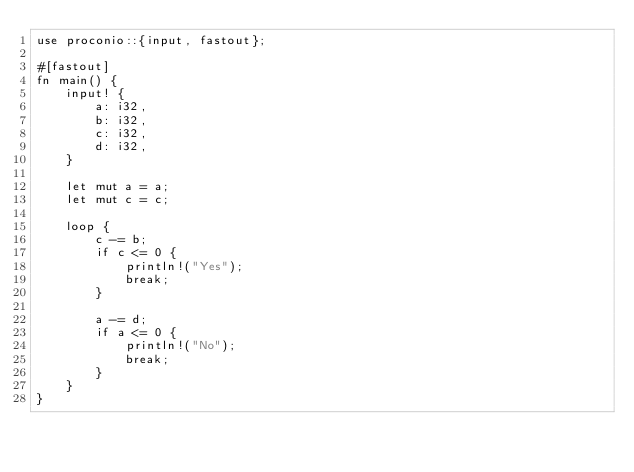Convert code to text. <code><loc_0><loc_0><loc_500><loc_500><_Rust_>use proconio::{input, fastout};

#[fastout]
fn main() {
    input! {
        a: i32,
        b: i32,
        c: i32,
        d: i32,
    }

    let mut a = a;
    let mut c = c;

    loop {
        c -= b;
        if c <= 0 {
            println!("Yes");
            break;
        }

        a -= d;
        if a <= 0 {
            println!("No");
            break;
        }
    }
}</code> 